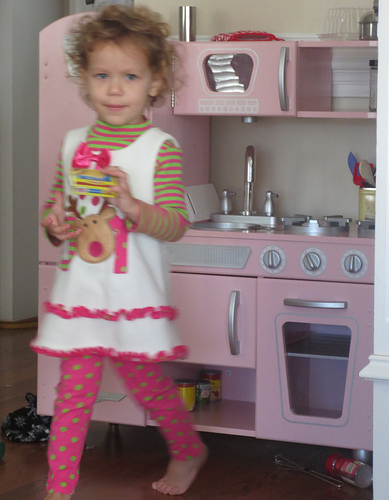<image>
Is there a girl on the cabinet? No. The girl is not positioned on the cabinet. They may be near each other, but the girl is not supported by or resting on top of the cabinet. Is the can behind the girl? Yes. From this viewpoint, the can is positioned behind the girl, with the girl partially or fully occluding the can. 